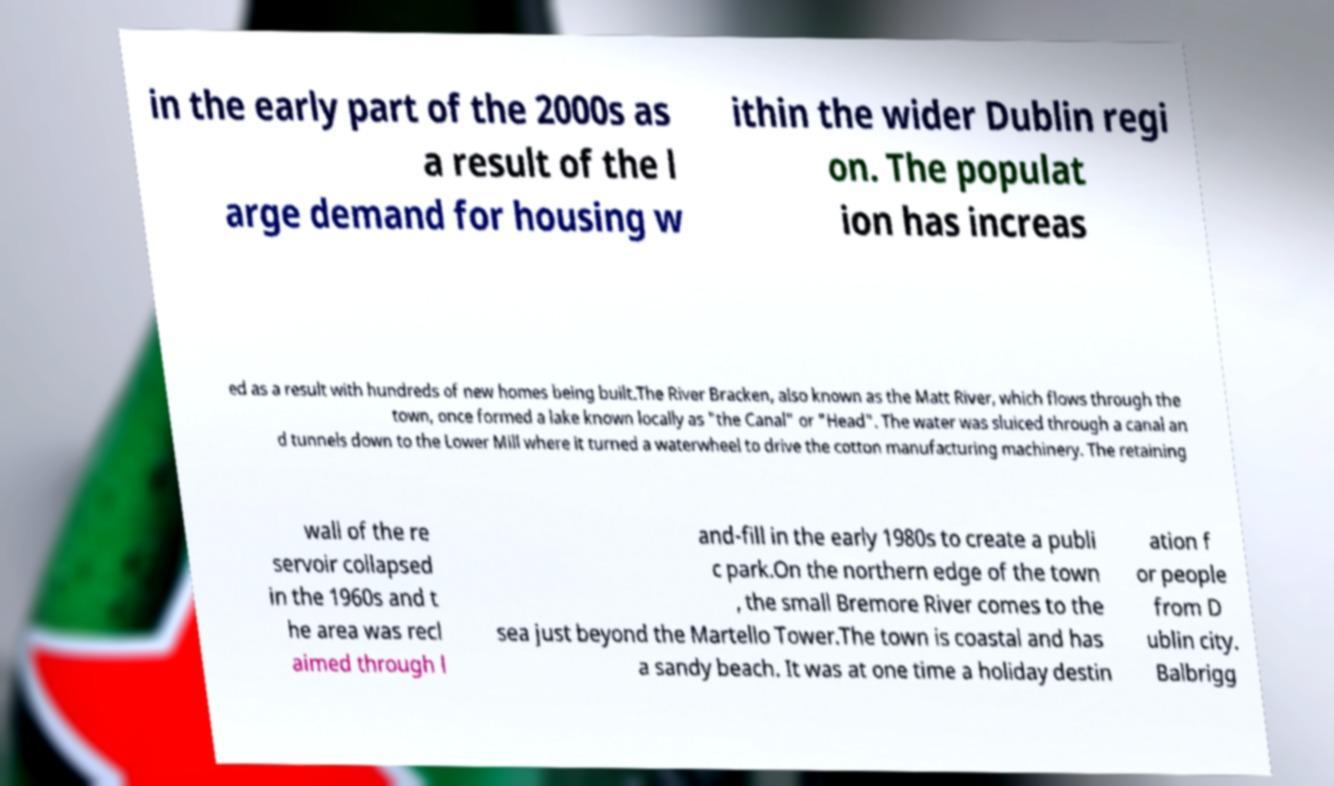For documentation purposes, I need the text within this image transcribed. Could you provide that? in the early part of the 2000s as a result of the l arge demand for housing w ithin the wider Dublin regi on. The populat ion has increas ed as a result with hundreds of new homes being built.The River Bracken, also known as the Matt River, which flows through the town, once formed a lake known locally as "the Canal" or "Head". The water was sluiced through a canal an d tunnels down to the Lower Mill where it turned a waterwheel to drive the cotton manufacturing machinery. The retaining wall of the re servoir collapsed in the 1960s and t he area was recl aimed through l and-fill in the early 1980s to create a publi c park.On the northern edge of the town , the small Bremore River comes to the sea just beyond the Martello Tower.The town is coastal and has a sandy beach. It was at one time a holiday destin ation f or people from D ublin city. Balbrigg 